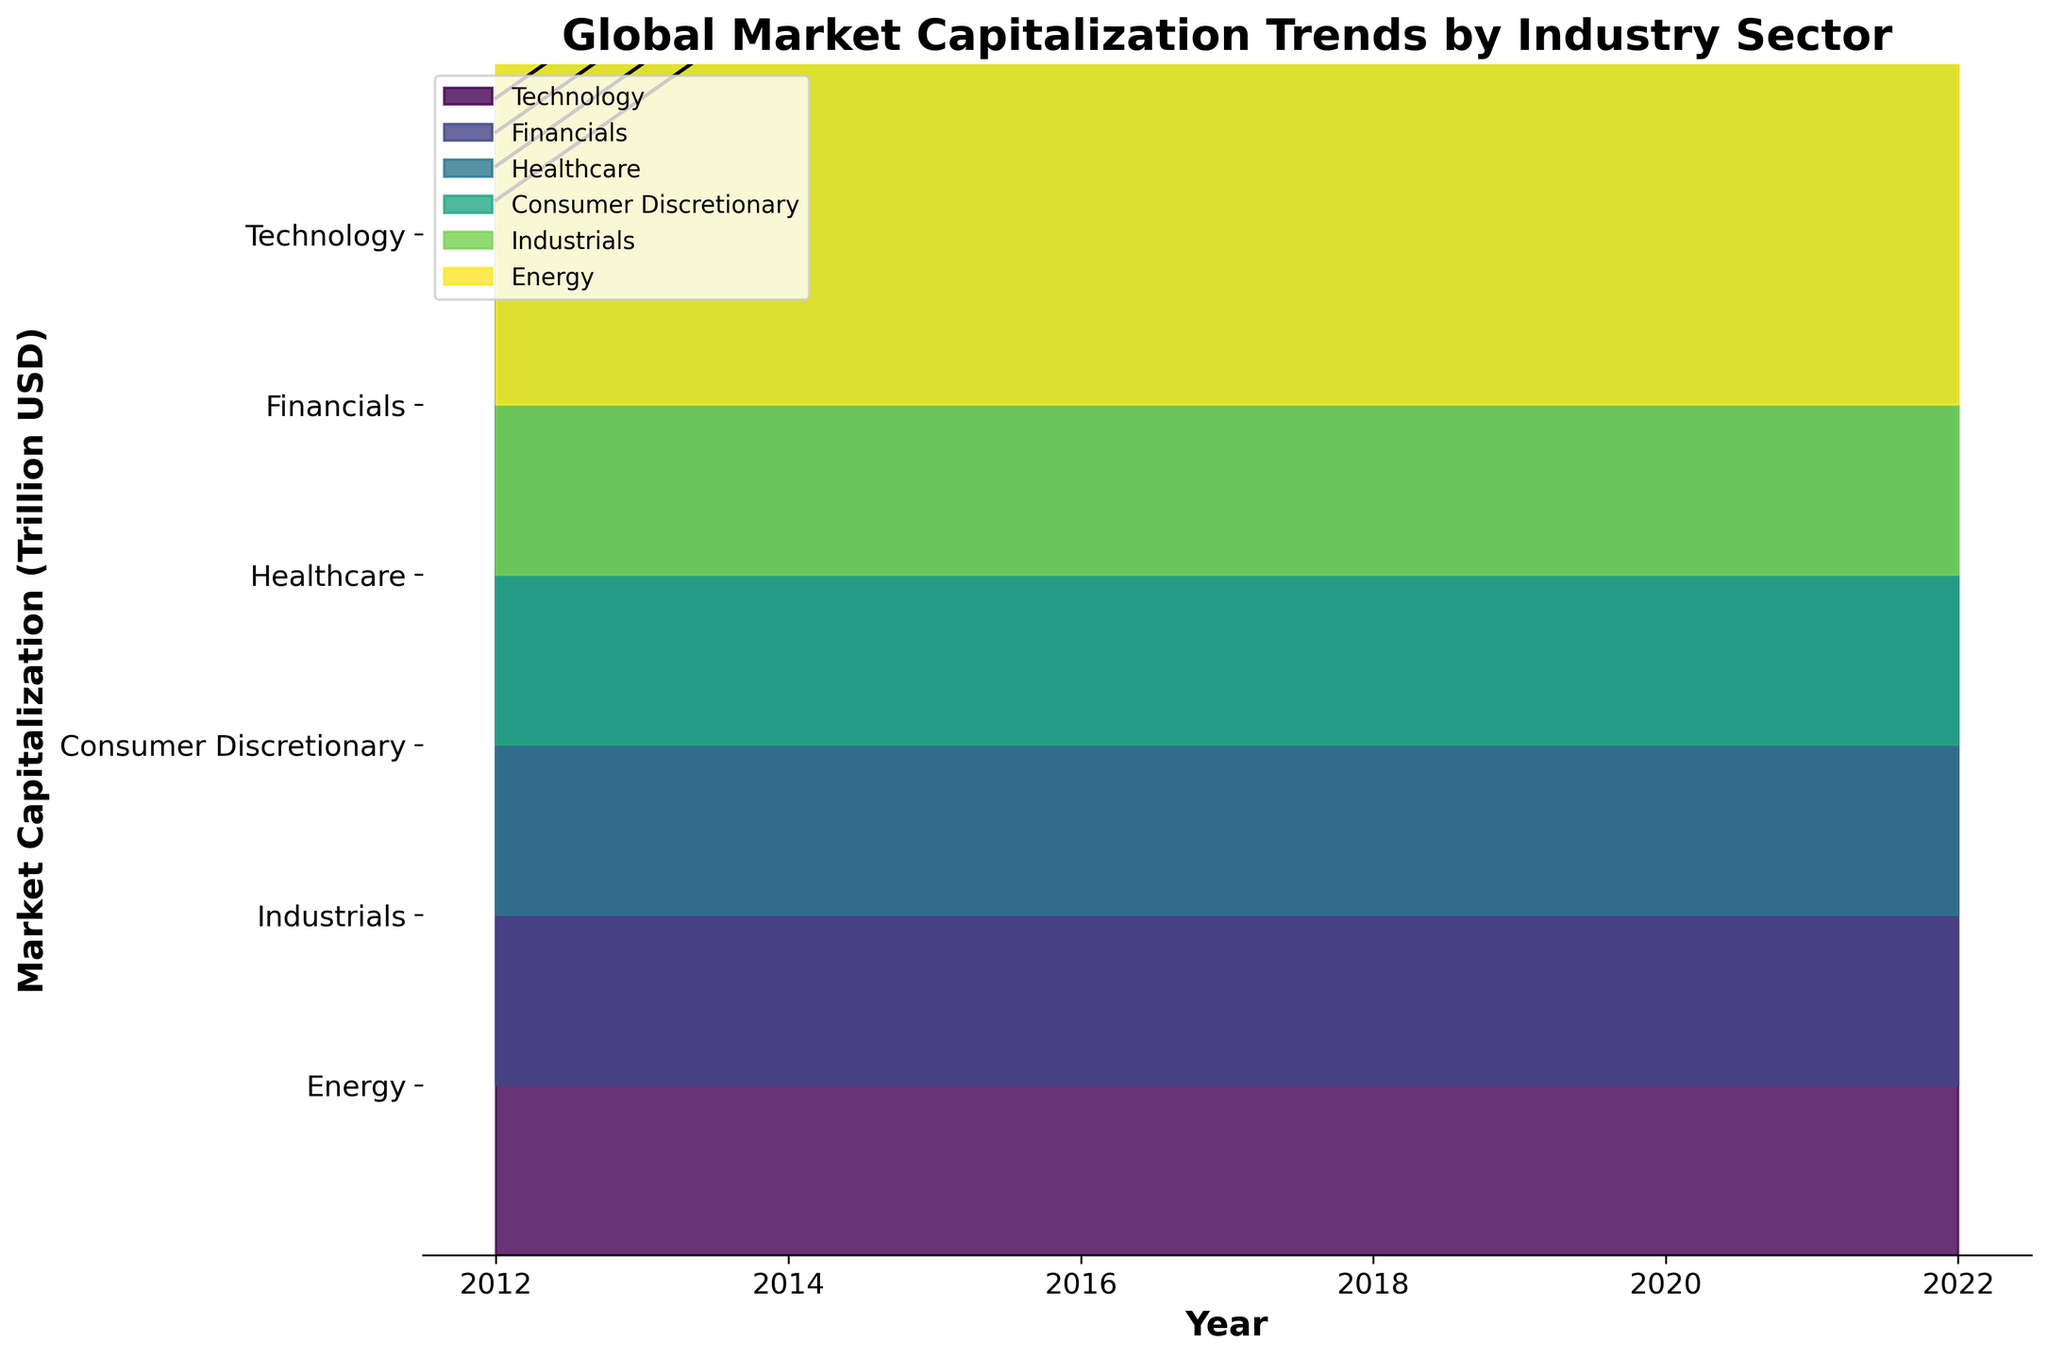What's the title of the plot? The title is written at the top of the figure, typically in a larger and bolder font. It directly provides the context of the visualization.
Answer: Global Market Capitalization Trends by Industry Sector Which sector had the highest market capitalization in 2021? By observing the top-most ridgeline in 2021 on the horizontal axis, we can see that Technology is the highest sector above all others.
Answer: Technology What's the general trend for the Energy sector over the decade? Looking at the Energy sector's ridgeline from 2012 to 2022, it appears mostly flat with slight fluctuations, indicating minimal to no significant growth over the years.
Answer: Mostly flat with slight fluctuations How much did the Healthcare sector's market capitalization increase from 2012 to 2022? The plot shows the Healthcare sector’s market capitalization at 2.1 trillion USD in 2012 and 4.4 trillion USD in 2022. The increase is 4.4 - 2.1 = 2.3 trillion USD.
Answer: 2.3 trillion USD Which two sectors had a drop in market capitalization in 2022 compared to 2021? By comparing the ridgelines in the years 2022 and 2021 along the horizontal axis, Technology and Financials sectors show a downward trend from 2021 to 2022.
Answer: Technology and Financials During which year did the Consumer Discretionary sector surpass 3 trillion USD in market capitalization? Observing the ridgeline of the Consumer Discretionary sector, it crossed the 3 trillion USD mark between 2017 and 2018. In 2018, it was slightly above 3 trillion USD.
Answer: 2018 How does the Industrials sector's market capitalization in 2020 compare to 2012? The plot shows Industrials at approximately 3.2 trillion USD in 2020, compared to 2.3 trillion USD in 2012. The difference is 3.2 - 2.3 = 0.9 trillion USD.
Answer: Higher by 0.9 trillion USD Rank the sectors by their market capitalization in 2015, from highest to lowest. By observing the ridgelines in 2015, we can rank them as follows: Technology (4.2), Financials (3.5), Healthcare (3.0), Industrials (2.7), Consumer Discretionary (2.6), Energy (2.1).
Answer: Technology, Financials, Healthcare, Industrials, Consumer Discretionary, Energy What was the impact of 2020 on the market capitalization of the Energy sector? In 2020, the plot shows a notable dip in the Energy sector’s market capitalization from previous years, decreasing to around 1.9 trillion USD.
Answer: Significant decrease Which sector showed the most consistent growth over the decade? Analyzing the ridgelines, Technology consistently shows an upward trajectory year over year without significant drops.
Answer: Technology 